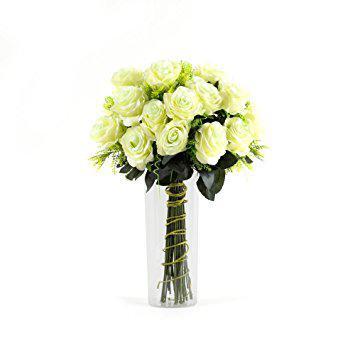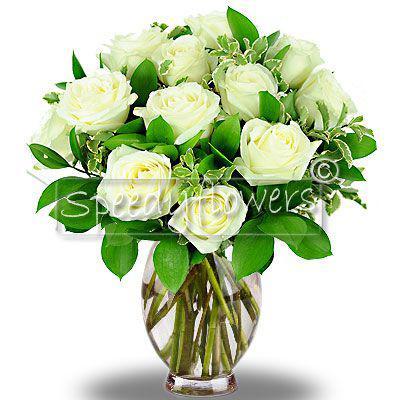The first image is the image on the left, the second image is the image on the right. Analyze the images presented: Is the assertion "There are a total of 6 red roses." valid? Answer yes or no. No. 